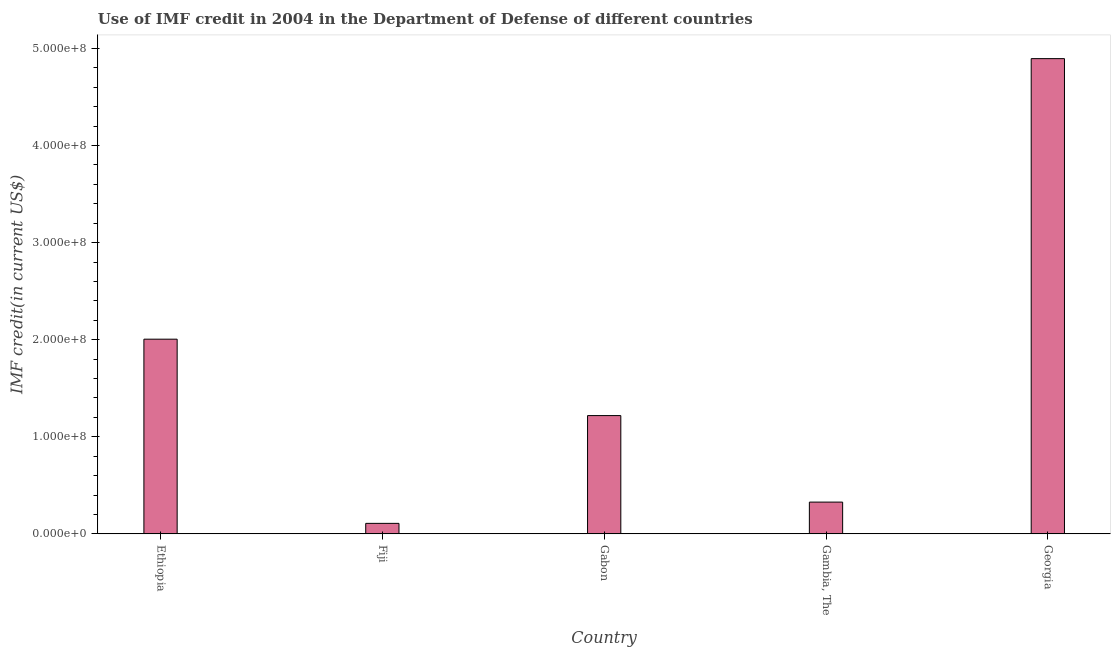Does the graph contain grids?
Your response must be concise. No. What is the title of the graph?
Ensure brevity in your answer.  Use of IMF credit in 2004 in the Department of Defense of different countries. What is the label or title of the X-axis?
Your answer should be very brief. Country. What is the label or title of the Y-axis?
Offer a very short reply. IMF credit(in current US$). What is the use of imf credit in dod in Fiji?
Ensure brevity in your answer.  1.08e+07. Across all countries, what is the maximum use of imf credit in dod?
Ensure brevity in your answer.  4.90e+08. Across all countries, what is the minimum use of imf credit in dod?
Your response must be concise. 1.08e+07. In which country was the use of imf credit in dod maximum?
Your answer should be compact. Georgia. In which country was the use of imf credit in dod minimum?
Your response must be concise. Fiji. What is the sum of the use of imf credit in dod?
Make the answer very short. 8.55e+08. What is the difference between the use of imf credit in dod in Ethiopia and Georgia?
Provide a short and direct response. -2.89e+08. What is the average use of imf credit in dod per country?
Ensure brevity in your answer.  1.71e+08. What is the median use of imf credit in dod?
Make the answer very short. 1.22e+08. In how many countries, is the use of imf credit in dod greater than 320000000 US$?
Give a very brief answer. 1. What is the ratio of the use of imf credit in dod in Gabon to that in Georgia?
Your answer should be compact. 0.25. Is the use of imf credit in dod in Fiji less than that in Georgia?
Your response must be concise. Yes. What is the difference between the highest and the second highest use of imf credit in dod?
Your answer should be compact. 2.89e+08. Is the sum of the use of imf credit in dod in Ethiopia and Fiji greater than the maximum use of imf credit in dod across all countries?
Your response must be concise. No. What is the difference between the highest and the lowest use of imf credit in dod?
Your answer should be compact. 4.79e+08. In how many countries, is the use of imf credit in dod greater than the average use of imf credit in dod taken over all countries?
Provide a short and direct response. 2. How many bars are there?
Give a very brief answer. 5. Are the values on the major ticks of Y-axis written in scientific E-notation?
Ensure brevity in your answer.  Yes. What is the IMF credit(in current US$) in Ethiopia?
Give a very brief answer. 2.01e+08. What is the IMF credit(in current US$) in Fiji?
Make the answer very short. 1.08e+07. What is the IMF credit(in current US$) in Gabon?
Ensure brevity in your answer.  1.22e+08. What is the IMF credit(in current US$) in Gambia, The?
Your response must be concise. 3.27e+07. What is the IMF credit(in current US$) of Georgia?
Your answer should be very brief. 4.90e+08. What is the difference between the IMF credit(in current US$) in Ethiopia and Fiji?
Provide a short and direct response. 1.90e+08. What is the difference between the IMF credit(in current US$) in Ethiopia and Gabon?
Your answer should be very brief. 7.87e+07. What is the difference between the IMF credit(in current US$) in Ethiopia and Gambia, The?
Give a very brief answer. 1.68e+08. What is the difference between the IMF credit(in current US$) in Ethiopia and Georgia?
Your answer should be very brief. -2.89e+08. What is the difference between the IMF credit(in current US$) in Fiji and Gabon?
Provide a succinct answer. -1.11e+08. What is the difference between the IMF credit(in current US$) in Fiji and Gambia, The?
Provide a short and direct response. -2.19e+07. What is the difference between the IMF credit(in current US$) in Fiji and Georgia?
Ensure brevity in your answer.  -4.79e+08. What is the difference between the IMF credit(in current US$) in Gabon and Gambia, The?
Your answer should be compact. 8.91e+07. What is the difference between the IMF credit(in current US$) in Gabon and Georgia?
Keep it short and to the point. -3.68e+08. What is the difference between the IMF credit(in current US$) in Gambia, The and Georgia?
Your answer should be very brief. -4.57e+08. What is the ratio of the IMF credit(in current US$) in Ethiopia to that in Fiji?
Provide a short and direct response. 18.56. What is the ratio of the IMF credit(in current US$) in Ethiopia to that in Gabon?
Ensure brevity in your answer.  1.65. What is the ratio of the IMF credit(in current US$) in Ethiopia to that in Gambia, The?
Ensure brevity in your answer.  6.13. What is the ratio of the IMF credit(in current US$) in Ethiopia to that in Georgia?
Offer a very short reply. 0.41. What is the ratio of the IMF credit(in current US$) in Fiji to that in Gabon?
Make the answer very short. 0.09. What is the ratio of the IMF credit(in current US$) in Fiji to that in Gambia, The?
Offer a very short reply. 0.33. What is the ratio of the IMF credit(in current US$) in Fiji to that in Georgia?
Provide a succinct answer. 0.02. What is the ratio of the IMF credit(in current US$) in Gabon to that in Gambia, The?
Offer a very short reply. 3.72. What is the ratio of the IMF credit(in current US$) in Gabon to that in Georgia?
Offer a terse response. 0.25. What is the ratio of the IMF credit(in current US$) in Gambia, The to that in Georgia?
Provide a short and direct response. 0.07. 